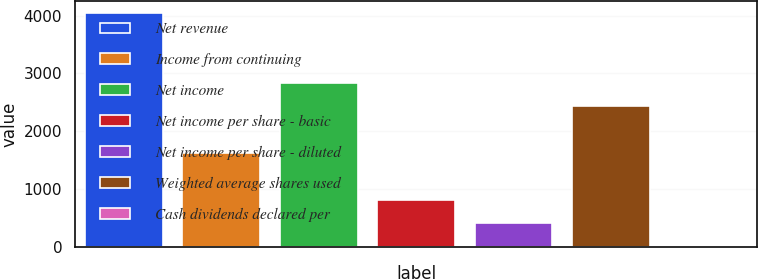Convert chart. <chart><loc_0><loc_0><loc_500><loc_500><bar_chart><fcel>Net revenue<fcel>Income from continuing<fcel>Net income<fcel>Net income per share - basic<fcel>Net income per share - diluted<fcel>Weighted average shares used<fcel>Cash dividends declared per<nl><fcel>4048<fcel>1619.53<fcel>2833.78<fcel>810.03<fcel>405.28<fcel>2429.03<fcel>0.53<nl></chart> 